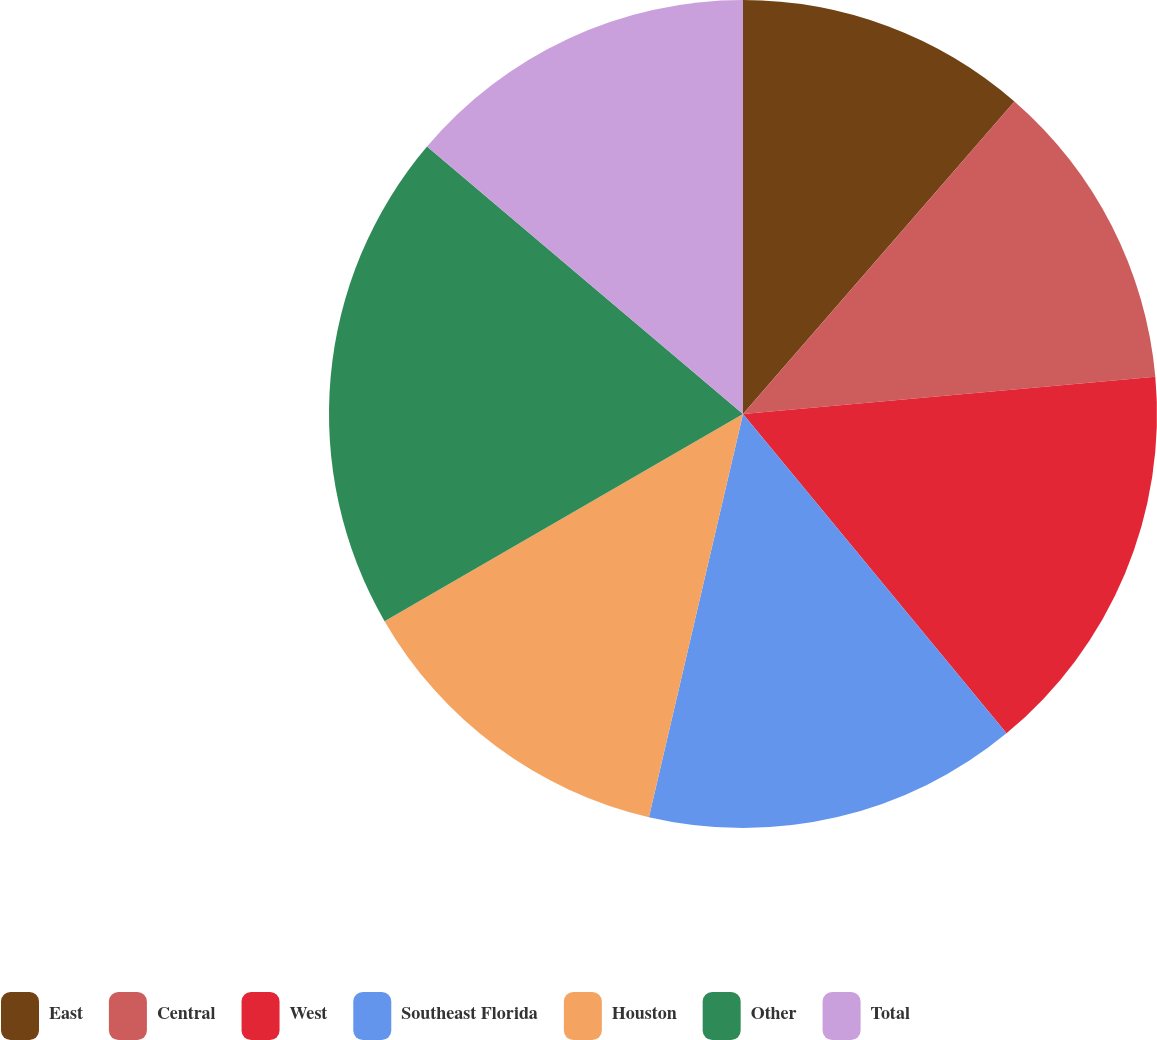Convert chart to OTSL. <chart><loc_0><loc_0><loc_500><loc_500><pie_chart><fcel>East<fcel>Central<fcel>West<fcel>Southeast Florida<fcel>Houston<fcel>Other<fcel>Total<nl><fcel>11.38%<fcel>12.19%<fcel>15.45%<fcel>14.63%<fcel>13.01%<fcel>19.52%<fcel>13.82%<nl></chart> 